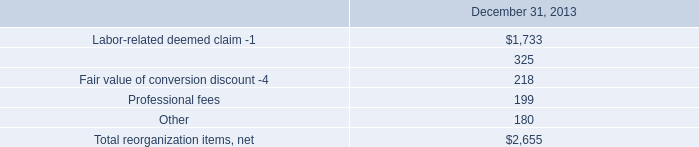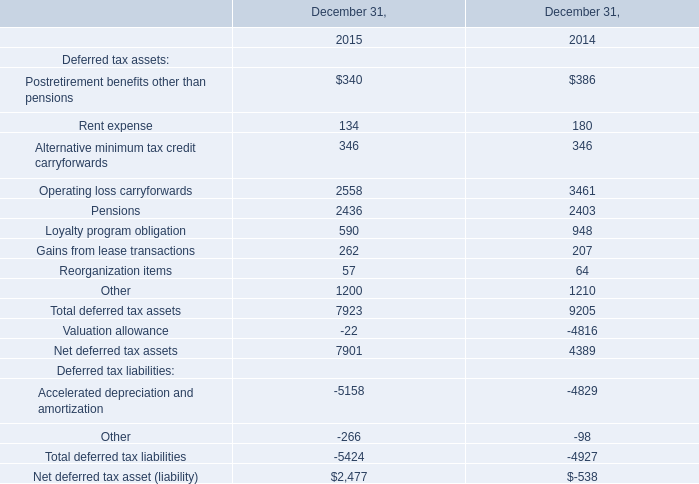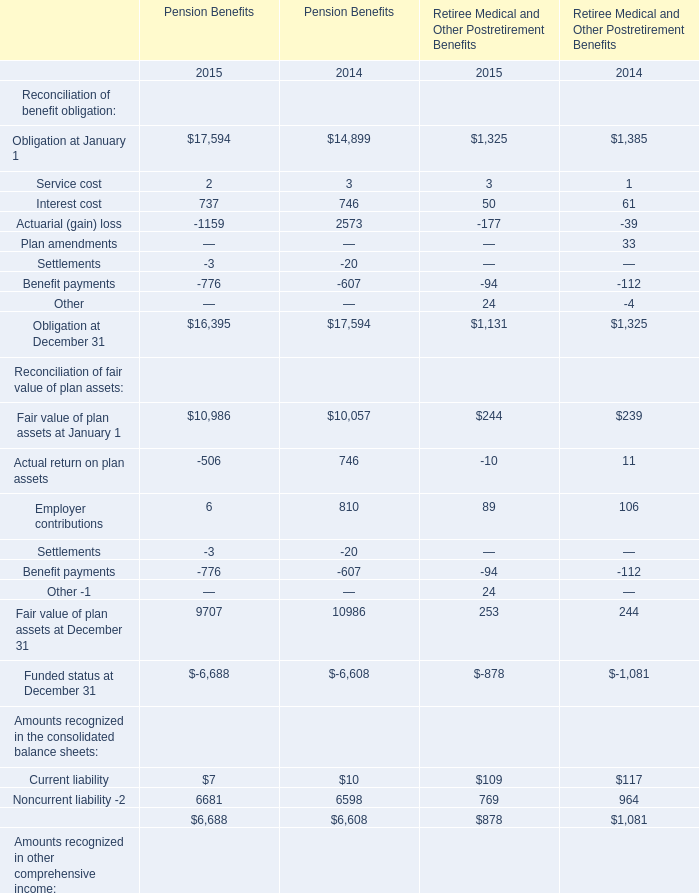What is the sum of Pensions of December 31, 2015, and Obligation at January 1 of Pension Benefits 2014 ? 
Computations: (2436.0 + 14899.0)
Answer: 17335.0. 